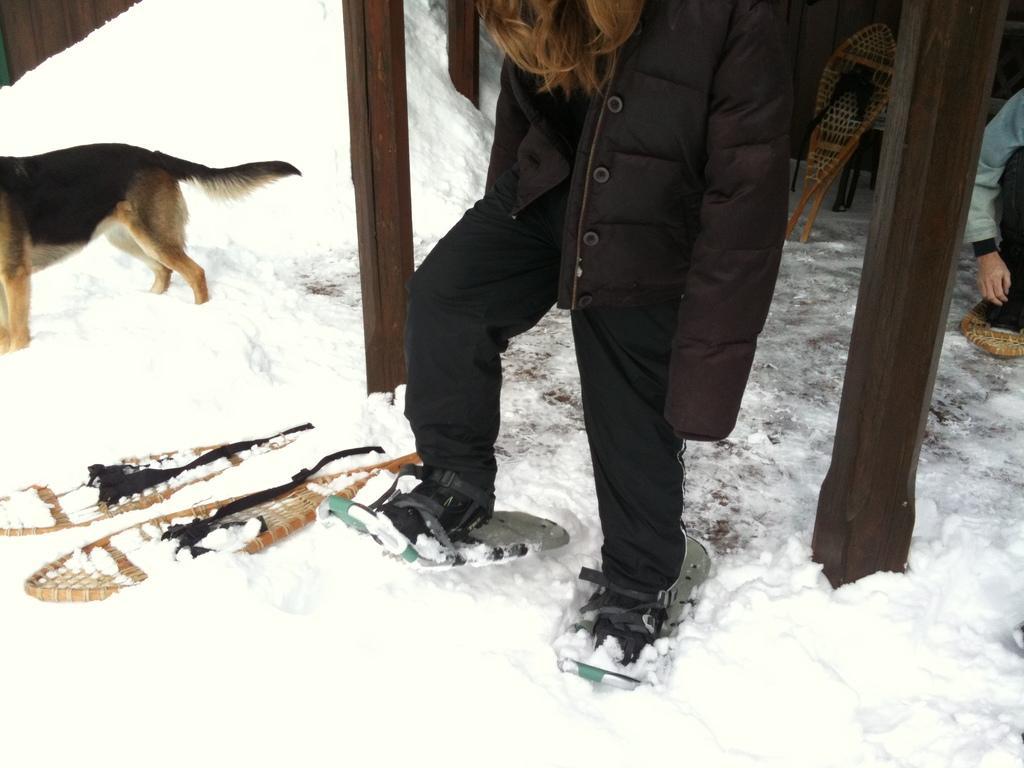Can you describe this image briefly? In this image I can see the person is wearing ski-board. I can see few objects, snow and an animal in brown and black color. 